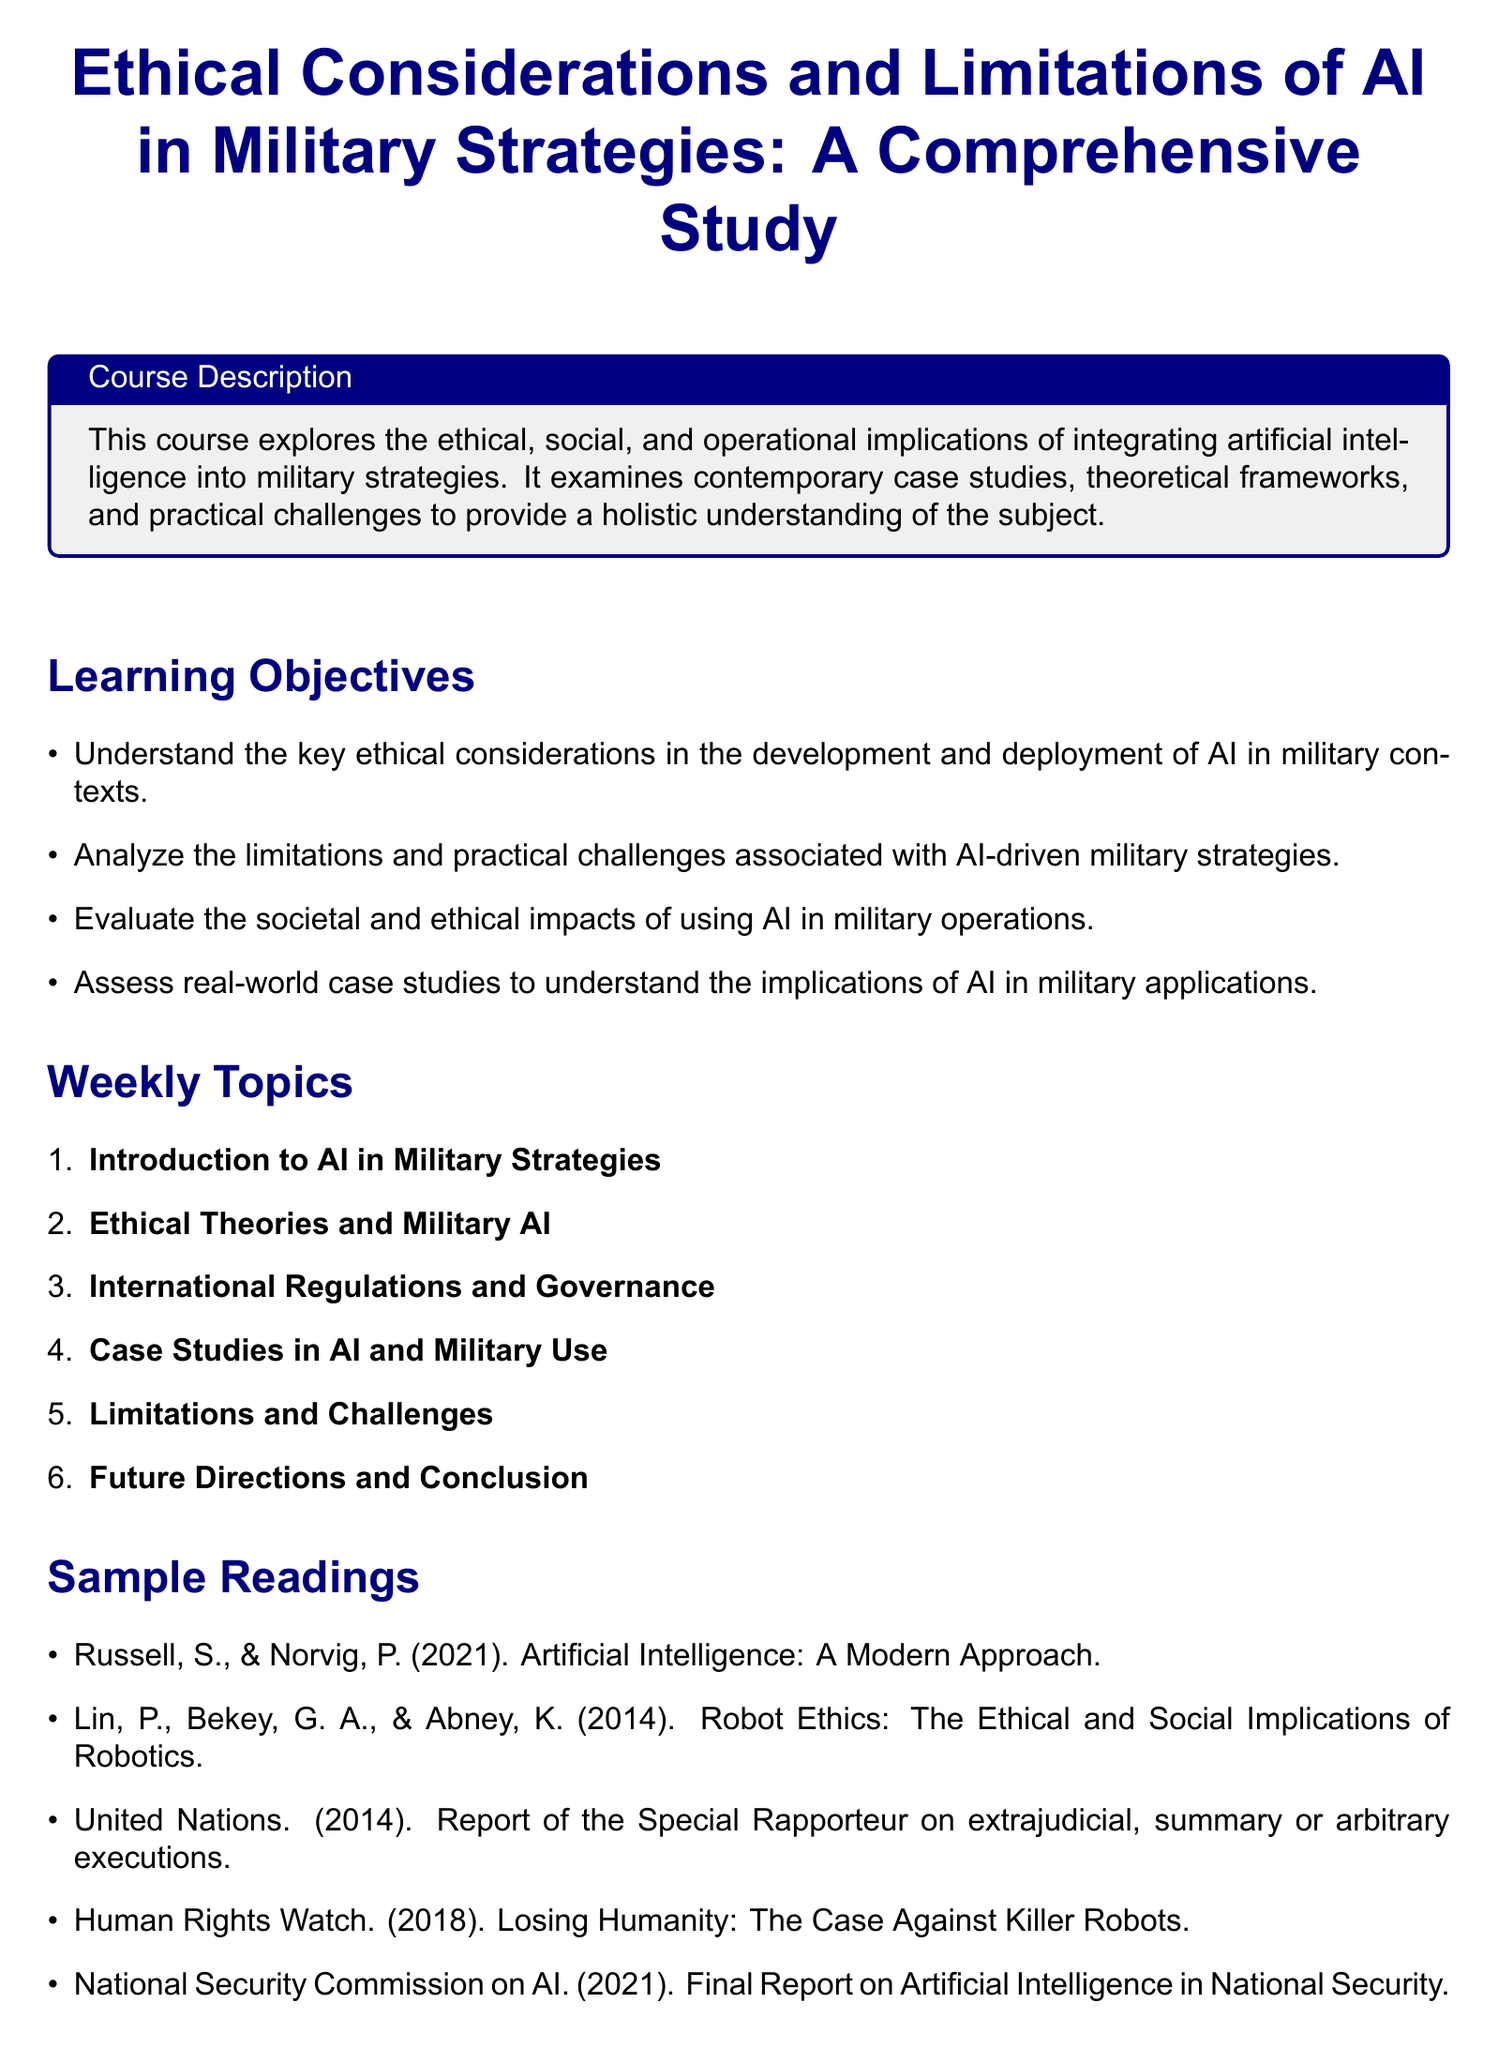what is the title of the course? The title is given at the beginning of the syllabus as "Ethical Considerations and Limitations of AI in Military Strategies: A Comprehensive Study."
Answer: Ethical Considerations and Limitations of AI in Military Strategies: A Comprehensive Study what is one of the learning objectives? The learning objectives are listed in a bullet-point format; one of them is to "Understand the key ethical considerations in the development and deployment of AI in military contexts."
Answer: Understand the key ethical considerations in the development and deployment of AI in military contexts how many weekly topics are there? The weekly topics are enumerated from 1 to 6, indicating a total of 6 weekly topics.
Answer: 6 name one sample reading. The document lists multiple readings; one example is "Russell, S., & Norvig, P. (2021). Artificial Intelligence: A Modern Approach."
Answer: Russell, S., & Norvig, P. (2021). Artificial Intelligence: A Modern Approach what is the assessment method? The assessment methods include various components; one of them is "Weekly Quizzes."
Answer: Weekly Quizzes which week discusses international regulations? The syllabus indicates that "International Regulations and Governance" is covered in week 3.
Answer: week 3 what is the color of the course title? The course title is formatted in navy blue color, as described in the document style.
Answer: navy blue what is the document type? The type of document is a syllabus, as it outlines a course description, objectives, topics, and assessments.
Answer: syllabus 